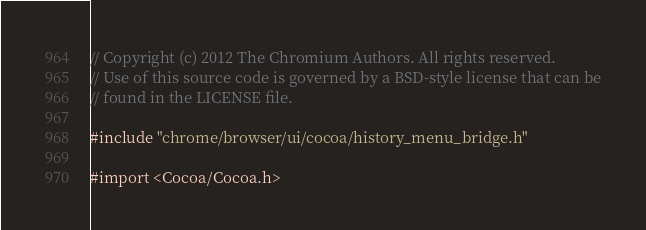<code> <loc_0><loc_0><loc_500><loc_500><_ObjectiveC_>// Copyright (c) 2012 The Chromium Authors. All rights reserved.
// Use of this source code is governed by a BSD-style license that can be
// found in the LICENSE file.

#include "chrome/browser/ui/cocoa/history_menu_bridge.h"

#import <Cocoa/Cocoa.h>
</code> 